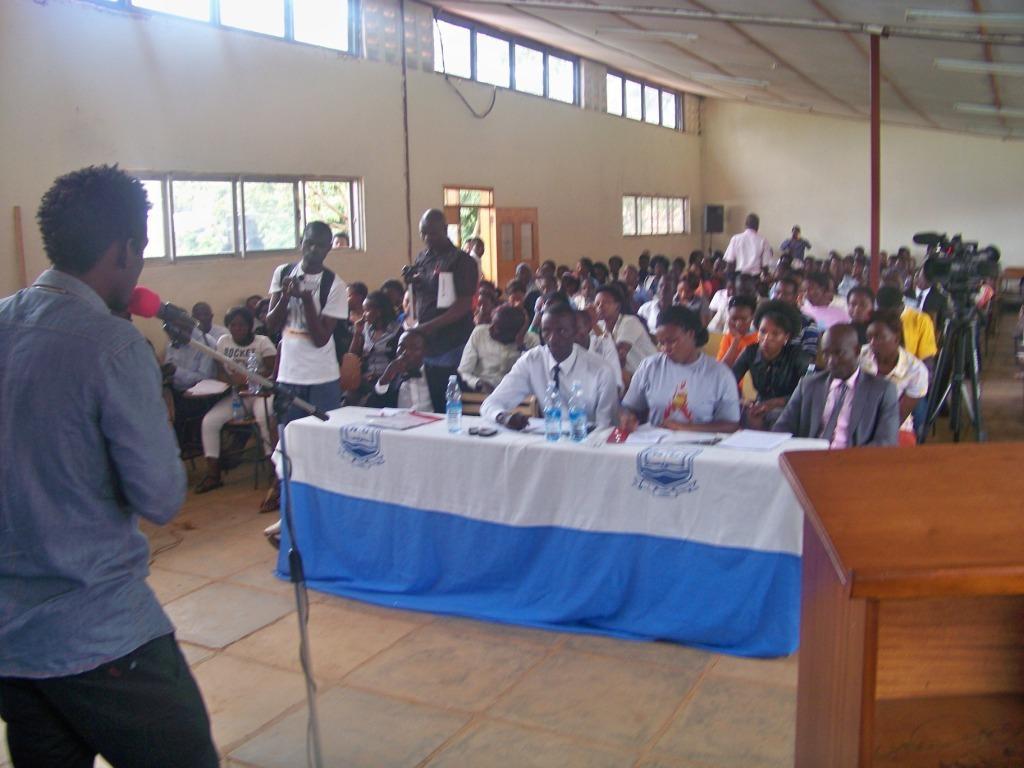Please provide a concise description of this image. In the image I can see there are so many people sitting and standing in a hall, in-front of them there is a table with cloth and bottles, also there is another man standing and speaking in a microphone beside him there is a table. 